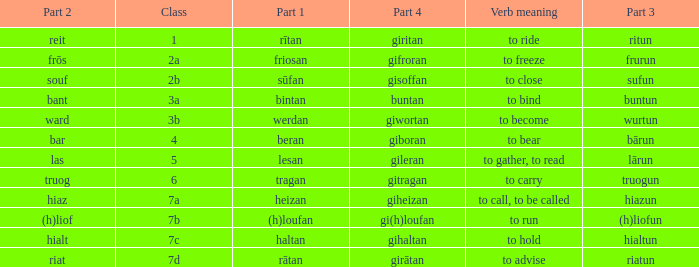What is the verb meaning of the word with part 2 "bant"? To bind. 